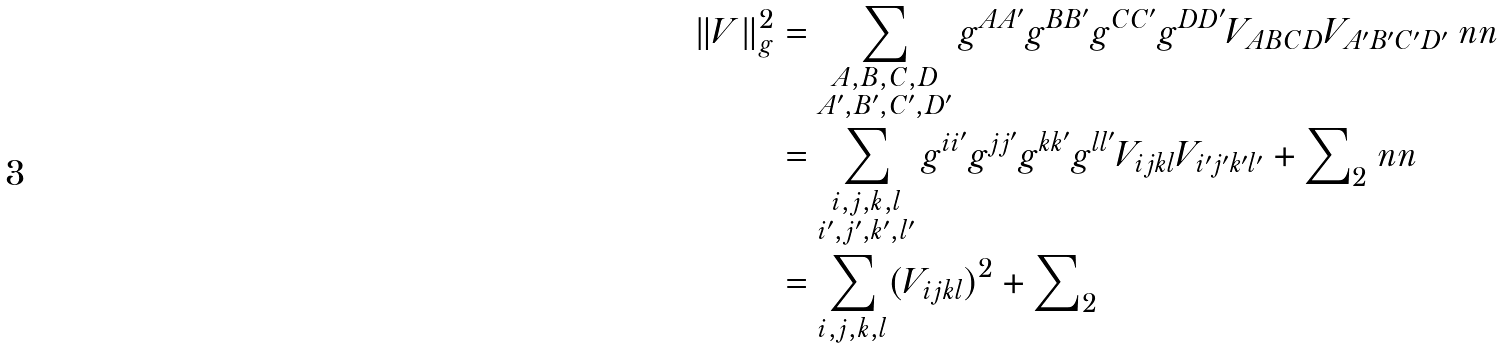Convert formula to latex. <formula><loc_0><loc_0><loc_500><loc_500>\| V \| _ { g } ^ { 2 } & = \sum _ { \substack { A , B , C , D \\ A ^ { \prime } , B ^ { \prime } , C ^ { \prime } , D ^ { \prime } } } g ^ { A A ^ { \prime } } g ^ { B B ^ { \prime } } g ^ { C C ^ { \prime } } g ^ { D D ^ { \prime } } V _ { A B C D } V _ { A ^ { \prime } B ^ { \prime } C ^ { \prime } D ^ { \prime } } \ n n \\ & = \sum _ { \substack { i , j , k , l \\ i ^ { \prime } , j ^ { \prime } , k ^ { \prime } , l ^ { \prime } } } g ^ { i i ^ { \prime } } g ^ { j j ^ { \prime } } g ^ { k k ^ { \prime } } g ^ { l l ^ { \prime } } V _ { i j k l } V _ { i ^ { \prime } j ^ { \prime } k ^ { \prime } l ^ { \prime } } + { \sum } _ { 2 } \ n n \\ & = \sum _ { i , j , k , l } ( V _ { i j k l } ) ^ { 2 } + { \sum } _ { 2 }</formula> 